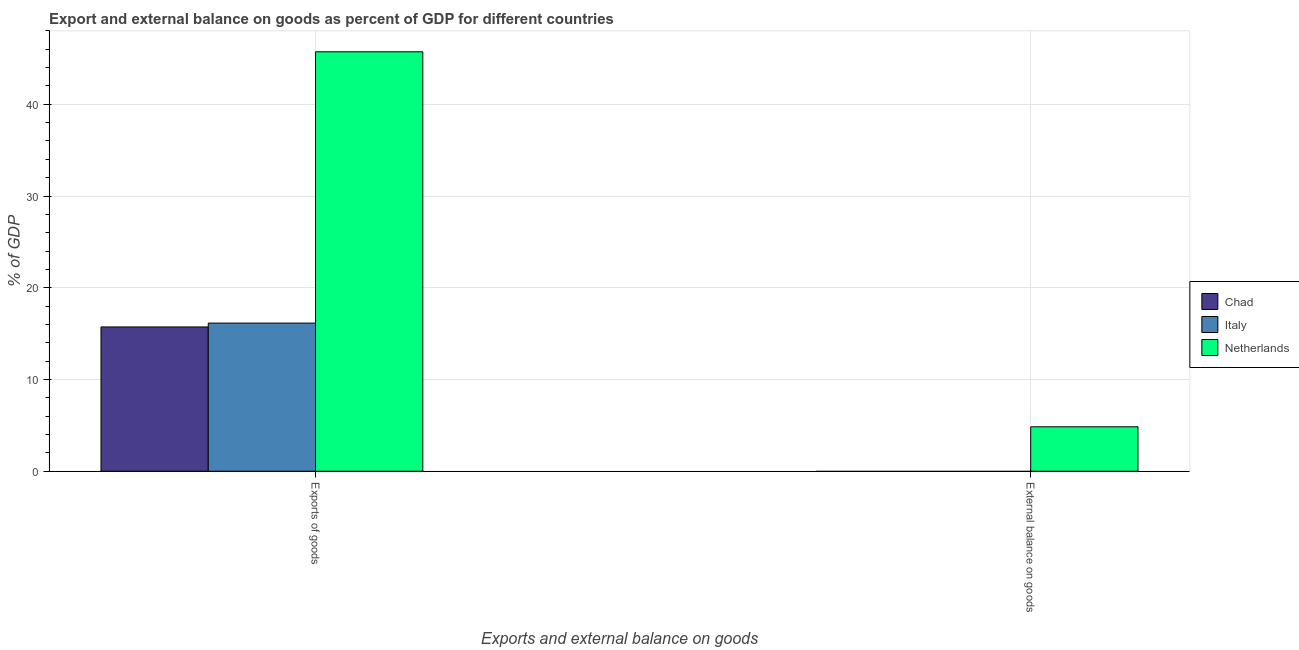Are the number of bars on each tick of the X-axis equal?
Keep it short and to the point. No. How many bars are there on the 2nd tick from the left?
Your answer should be compact. 1. How many bars are there on the 1st tick from the right?
Your answer should be compact. 1. What is the label of the 2nd group of bars from the left?
Keep it short and to the point. External balance on goods. What is the export of goods as percentage of gdp in Netherlands?
Make the answer very short. 45.72. Across all countries, what is the maximum external balance on goods as percentage of gdp?
Your answer should be very brief. 4.84. In which country was the export of goods as percentage of gdp maximum?
Offer a very short reply. Netherlands. What is the total external balance on goods as percentage of gdp in the graph?
Your answer should be very brief. 4.84. What is the difference between the export of goods as percentage of gdp in Italy and that in Netherlands?
Provide a short and direct response. -29.57. What is the difference between the external balance on goods as percentage of gdp in Netherlands and the export of goods as percentage of gdp in Chad?
Ensure brevity in your answer.  -10.89. What is the average export of goods as percentage of gdp per country?
Your response must be concise. 25.87. What is the difference between the export of goods as percentage of gdp and external balance on goods as percentage of gdp in Netherlands?
Offer a terse response. 40.88. In how many countries, is the external balance on goods as percentage of gdp greater than 44 %?
Your response must be concise. 0. What is the ratio of the export of goods as percentage of gdp in Netherlands to that in Chad?
Provide a succinct answer. 2.91. Is the export of goods as percentage of gdp in Netherlands less than that in Italy?
Provide a succinct answer. No. How many countries are there in the graph?
Ensure brevity in your answer.  3. What is the difference between two consecutive major ticks on the Y-axis?
Make the answer very short. 10. Does the graph contain any zero values?
Your response must be concise. Yes. Does the graph contain grids?
Ensure brevity in your answer.  Yes. How are the legend labels stacked?
Your response must be concise. Vertical. What is the title of the graph?
Keep it short and to the point. Export and external balance on goods as percent of GDP for different countries. What is the label or title of the X-axis?
Ensure brevity in your answer.  Exports and external balance on goods. What is the label or title of the Y-axis?
Your answer should be very brief. % of GDP. What is the % of GDP of Chad in Exports of goods?
Your response must be concise. 15.73. What is the % of GDP in Italy in Exports of goods?
Provide a short and direct response. 16.15. What is the % of GDP in Netherlands in Exports of goods?
Your response must be concise. 45.72. What is the % of GDP in Chad in External balance on goods?
Ensure brevity in your answer.  0. What is the % of GDP in Italy in External balance on goods?
Provide a short and direct response. 0. What is the % of GDP in Netherlands in External balance on goods?
Provide a succinct answer. 4.84. Across all Exports and external balance on goods, what is the maximum % of GDP of Chad?
Offer a very short reply. 15.73. Across all Exports and external balance on goods, what is the maximum % of GDP in Italy?
Your answer should be very brief. 16.15. Across all Exports and external balance on goods, what is the maximum % of GDP in Netherlands?
Your response must be concise. 45.72. Across all Exports and external balance on goods, what is the minimum % of GDP in Chad?
Your answer should be very brief. 0. Across all Exports and external balance on goods, what is the minimum % of GDP in Netherlands?
Keep it short and to the point. 4.84. What is the total % of GDP in Chad in the graph?
Your answer should be very brief. 15.73. What is the total % of GDP in Italy in the graph?
Provide a short and direct response. 16.15. What is the total % of GDP in Netherlands in the graph?
Make the answer very short. 50.57. What is the difference between the % of GDP of Netherlands in Exports of goods and that in External balance on goods?
Provide a short and direct response. 40.88. What is the difference between the % of GDP in Chad in Exports of goods and the % of GDP in Netherlands in External balance on goods?
Keep it short and to the point. 10.89. What is the difference between the % of GDP of Italy in Exports of goods and the % of GDP of Netherlands in External balance on goods?
Make the answer very short. 11.31. What is the average % of GDP in Chad per Exports and external balance on goods?
Make the answer very short. 7.86. What is the average % of GDP of Italy per Exports and external balance on goods?
Offer a very short reply. 8.07. What is the average % of GDP in Netherlands per Exports and external balance on goods?
Your answer should be compact. 25.28. What is the difference between the % of GDP in Chad and % of GDP in Italy in Exports of goods?
Provide a succinct answer. -0.42. What is the difference between the % of GDP in Chad and % of GDP in Netherlands in Exports of goods?
Make the answer very short. -30. What is the difference between the % of GDP in Italy and % of GDP in Netherlands in Exports of goods?
Ensure brevity in your answer.  -29.57. What is the ratio of the % of GDP of Netherlands in Exports of goods to that in External balance on goods?
Keep it short and to the point. 9.44. What is the difference between the highest and the second highest % of GDP of Netherlands?
Make the answer very short. 40.88. What is the difference between the highest and the lowest % of GDP in Chad?
Your response must be concise. 15.73. What is the difference between the highest and the lowest % of GDP of Italy?
Give a very brief answer. 16.15. What is the difference between the highest and the lowest % of GDP of Netherlands?
Offer a very short reply. 40.88. 